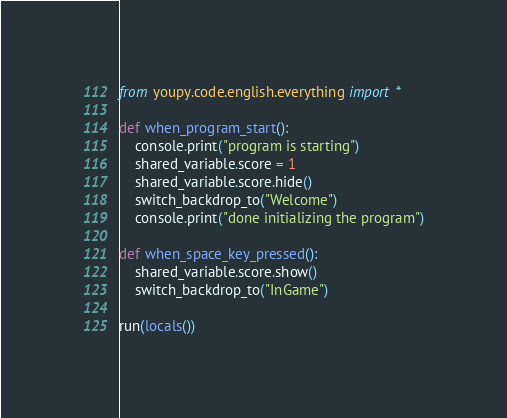Convert code to text. <code><loc_0><loc_0><loc_500><loc_500><_Python_>from youpy.code.english.everything import *

def when_program_start():
    console.print("program is starting")
    shared_variable.score = 1
    shared_variable.score.hide()
    switch_backdrop_to("Welcome")
    console.print("done initializing the program")

def when_space_key_pressed():
    shared_variable.score.show()
    switch_backdrop_to("InGame")

run(locals())
</code> 